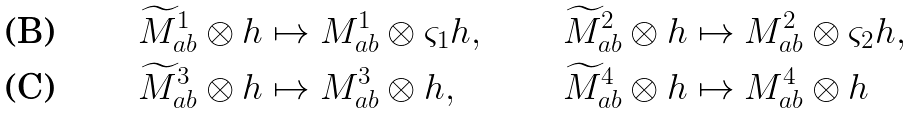Convert formula to latex. <formula><loc_0><loc_0><loc_500><loc_500>\widetilde { M } ^ { 1 } _ { a b } \otimes h & \mapsto M ^ { 1 } _ { a b } \otimes \varsigma _ { 1 } h , & \widetilde { M } ^ { 2 } _ { a b } \otimes h & \mapsto M ^ { 2 } _ { a b } \otimes \varsigma _ { 2 } h , \\ \widetilde { M } ^ { 3 } _ { a b } \otimes h & \mapsto M ^ { 3 } _ { a b } \otimes h , & \widetilde { M } ^ { 4 } _ { a b } \otimes h & \mapsto M ^ { 4 } _ { a b } \otimes h</formula> 